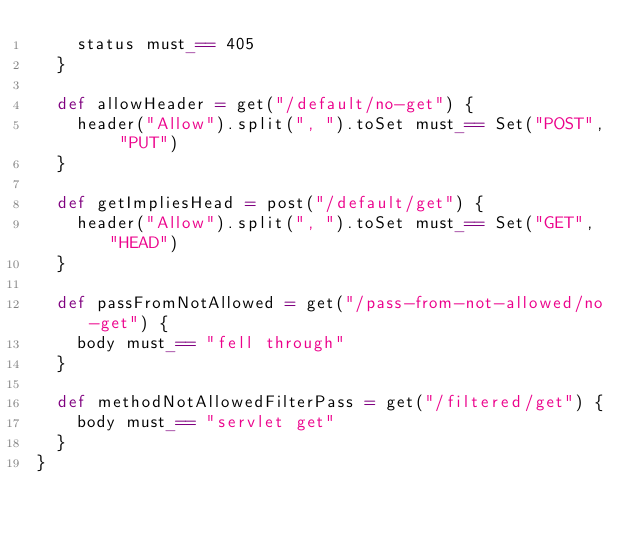Convert code to text. <code><loc_0><loc_0><loc_500><loc_500><_Scala_>    status must_== 405
  }

  def allowHeader = get("/default/no-get") {
    header("Allow").split(", ").toSet must_== Set("POST", "PUT")
  }

  def getImpliesHead = post("/default/get") {
    header("Allow").split(", ").toSet must_== Set("GET", "HEAD")
  }

  def passFromNotAllowed = get("/pass-from-not-allowed/no-get") {
    body must_== "fell through"
  }

  def methodNotAllowedFilterPass = get("/filtered/get") {
    body must_== "servlet get"
  }
}
</code> 